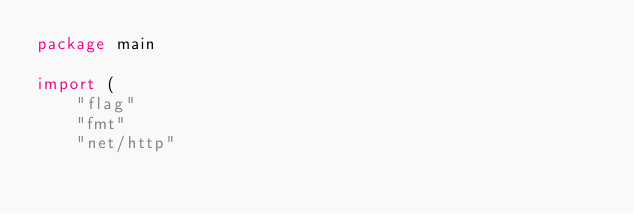Convert code to text. <code><loc_0><loc_0><loc_500><loc_500><_Go_>package main

import (
	"flag"
	"fmt"
	"net/http"</code> 